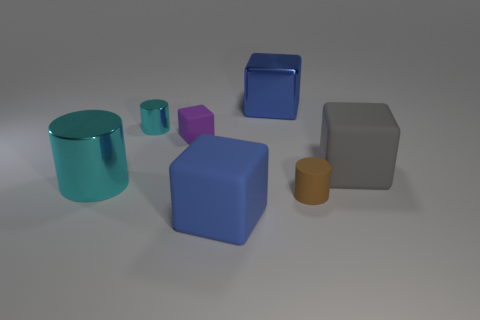Are there more metal cylinders behind the gray thing than small gray matte spheres?
Ensure brevity in your answer.  Yes. Does the large rubber object that is in front of the brown thing have the same shape as the large blue shiny thing?
Your answer should be very brief. Yes. How many things are gray rubber blocks or blocks to the right of the shiny cube?
Your response must be concise. 1. There is a cylinder that is on the right side of the large cylinder and in front of the small rubber block; what size is it?
Provide a short and direct response. Small. Is the number of things that are right of the large gray matte block greater than the number of small purple objects in front of the brown matte cylinder?
Keep it short and to the point. No. Do the large gray rubber object and the blue thing that is in front of the blue metallic object have the same shape?
Your answer should be compact. Yes. What number of other objects are the same shape as the large blue rubber object?
Offer a terse response. 3. There is a object that is behind the small purple rubber cube and left of the purple thing; what color is it?
Offer a very short reply. Cyan. The big metal block is what color?
Your answer should be compact. Blue. Does the gray thing have the same material as the small cylinder behind the large cyan object?
Your answer should be compact. No. 